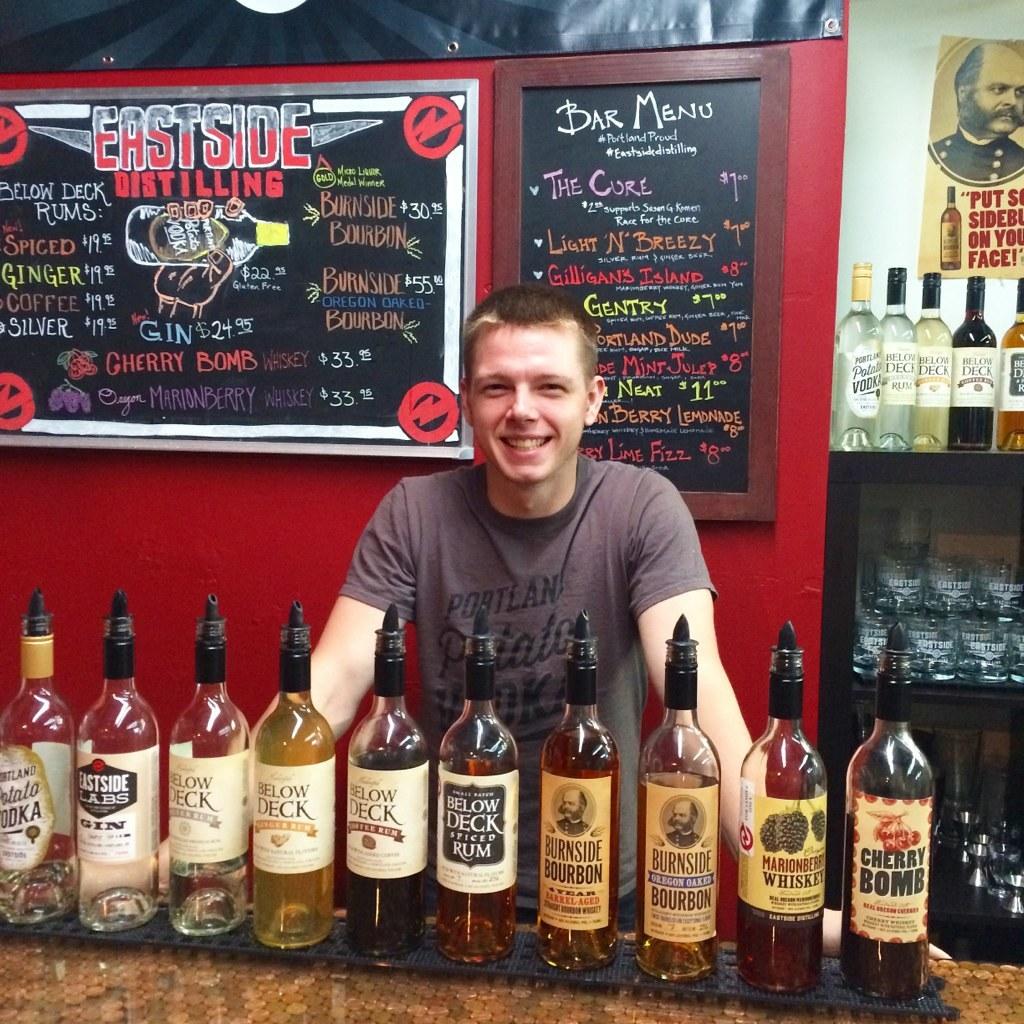Do they have a bar menu?
Ensure brevity in your answer.  Yes. 